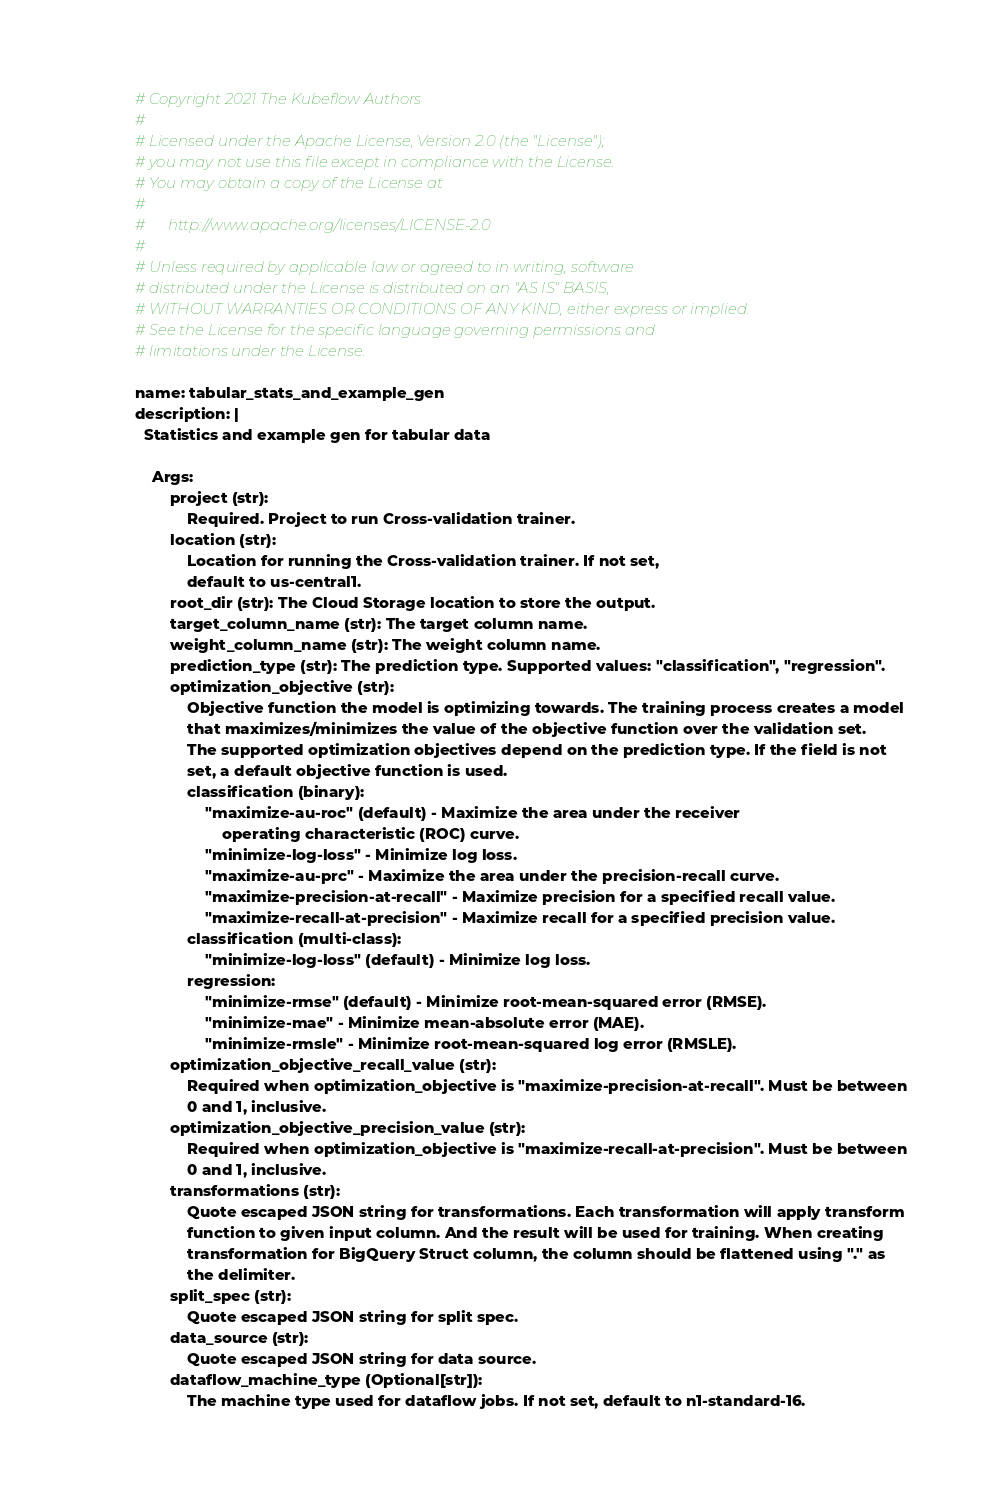Convert code to text. <code><loc_0><loc_0><loc_500><loc_500><_YAML_># Copyright 2021 The Kubeflow Authors
#
# Licensed under the Apache License, Version 2.0 (the "License");
# you may not use this file except in compliance with the License.
# You may obtain a copy of the License at
#
#      http://www.apache.org/licenses/LICENSE-2.0
#
# Unless required by applicable law or agreed to in writing, software
# distributed under the License is distributed on an "AS IS" BASIS,
# WITHOUT WARRANTIES OR CONDITIONS OF ANY KIND, either express or implied.
# See the License for the specific language governing permissions and
# limitations under the License.

name: tabular_stats_and_example_gen
description: |
  Statistics and example gen for tabular data

    Args:
        project (str):
            Required. Project to run Cross-validation trainer.
        location (str):
            Location for running the Cross-validation trainer. If not set,
            default to us-central1.
        root_dir (str): The Cloud Storage location to store the output.
        target_column_name (str): The target column name.
        weight_column_name (str): The weight column name.
        prediction_type (str): The prediction type. Supported values: "classification", "regression".
        optimization_objective (str):
            Objective function the model is optimizing towards. The training process creates a model
            that maximizes/minimizes the value of the objective function over the validation set.
            The supported optimization objectives depend on the prediction type. If the field is not
            set, a default objective function is used.
            classification (binary):
                "maximize-au-roc" (default) - Maximize the area under the receiver
                    operating characteristic (ROC) curve.
                "minimize-log-loss" - Minimize log loss.
                "maximize-au-prc" - Maximize the area under the precision-recall curve.
                "maximize-precision-at-recall" - Maximize precision for a specified recall value.
                "maximize-recall-at-precision" - Maximize recall for a specified precision value.
            classification (multi-class):
                "minimize-log-loss" (default) - Minimize log loss.
            regression:
                "minimize-rmse" (default) - Minimize root-mean-squared error (RMSE).
                "minimize-mae" - Minimize mean-absolute error (MAE).
                "minimize-rmsle" - Minimize root-mean-squared log error (RMSLE).
        optimization_objective_recall_value (str):
            Required when optimization_objective is "maximize-precision-at-recall". Must be between
            0 and 1, inclusive.
        optimization_objective_precision_value (str):
            Required when optimization_objective is "maximize-recall-at-precision". Must be between
            0 and 1, inclusive.
        transformations (str):
            Quote escaped JSON string for transformations. Each transformation will apply transform
            function to given input column. And the result will be used for training. When creating
            transformation for BigQuery Struct column, the column should be flattened using "." as
            the delimiter.
        split_spec (str):
            Quote escaped JSON string for split spec.
        data_source (str):
            Quote escaped JSON string for data source.
        dataflow_machine_type (Optional[str]):
            The machine type used for dataflow jobs. If not set, default to n1-standard-16.</code> 